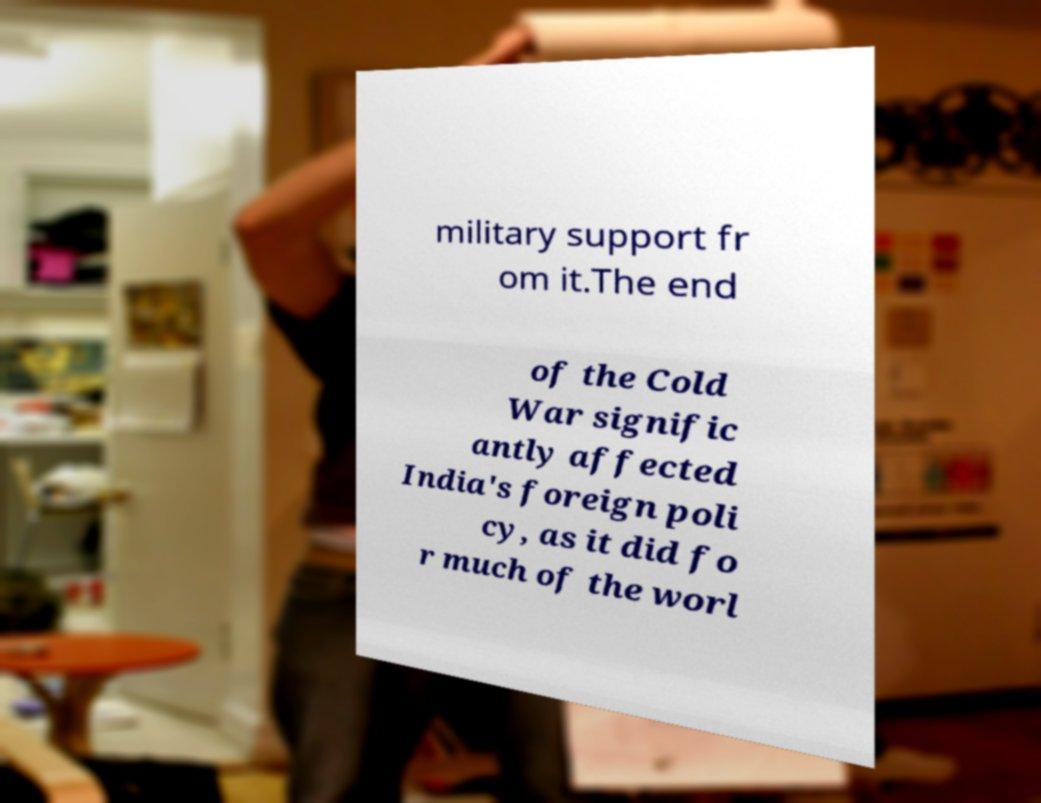Please identify and transcribe the text found in this image. military support fr om it.The end of the Cold War signific antly affected India's foreign poli cy, as it did fo r much of the worl 